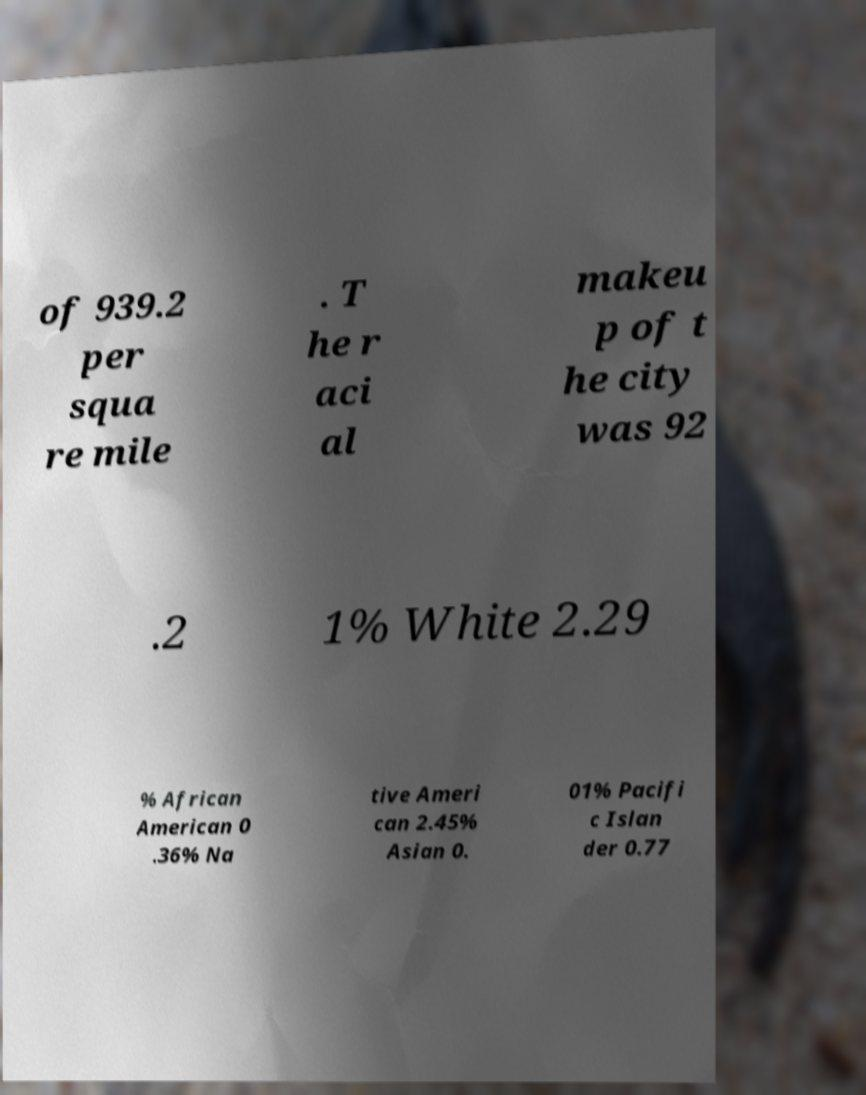Can you accurately transcribe the text from the provided image for me? of 939.2 per squa re mile . T he r aci al makeu p of t he city was 92 .2 1% White 2.29 % African American 0 .36% Na tive Ameri can 2.45% Asian 0. 01% Pacifi c Islan der 0.77 